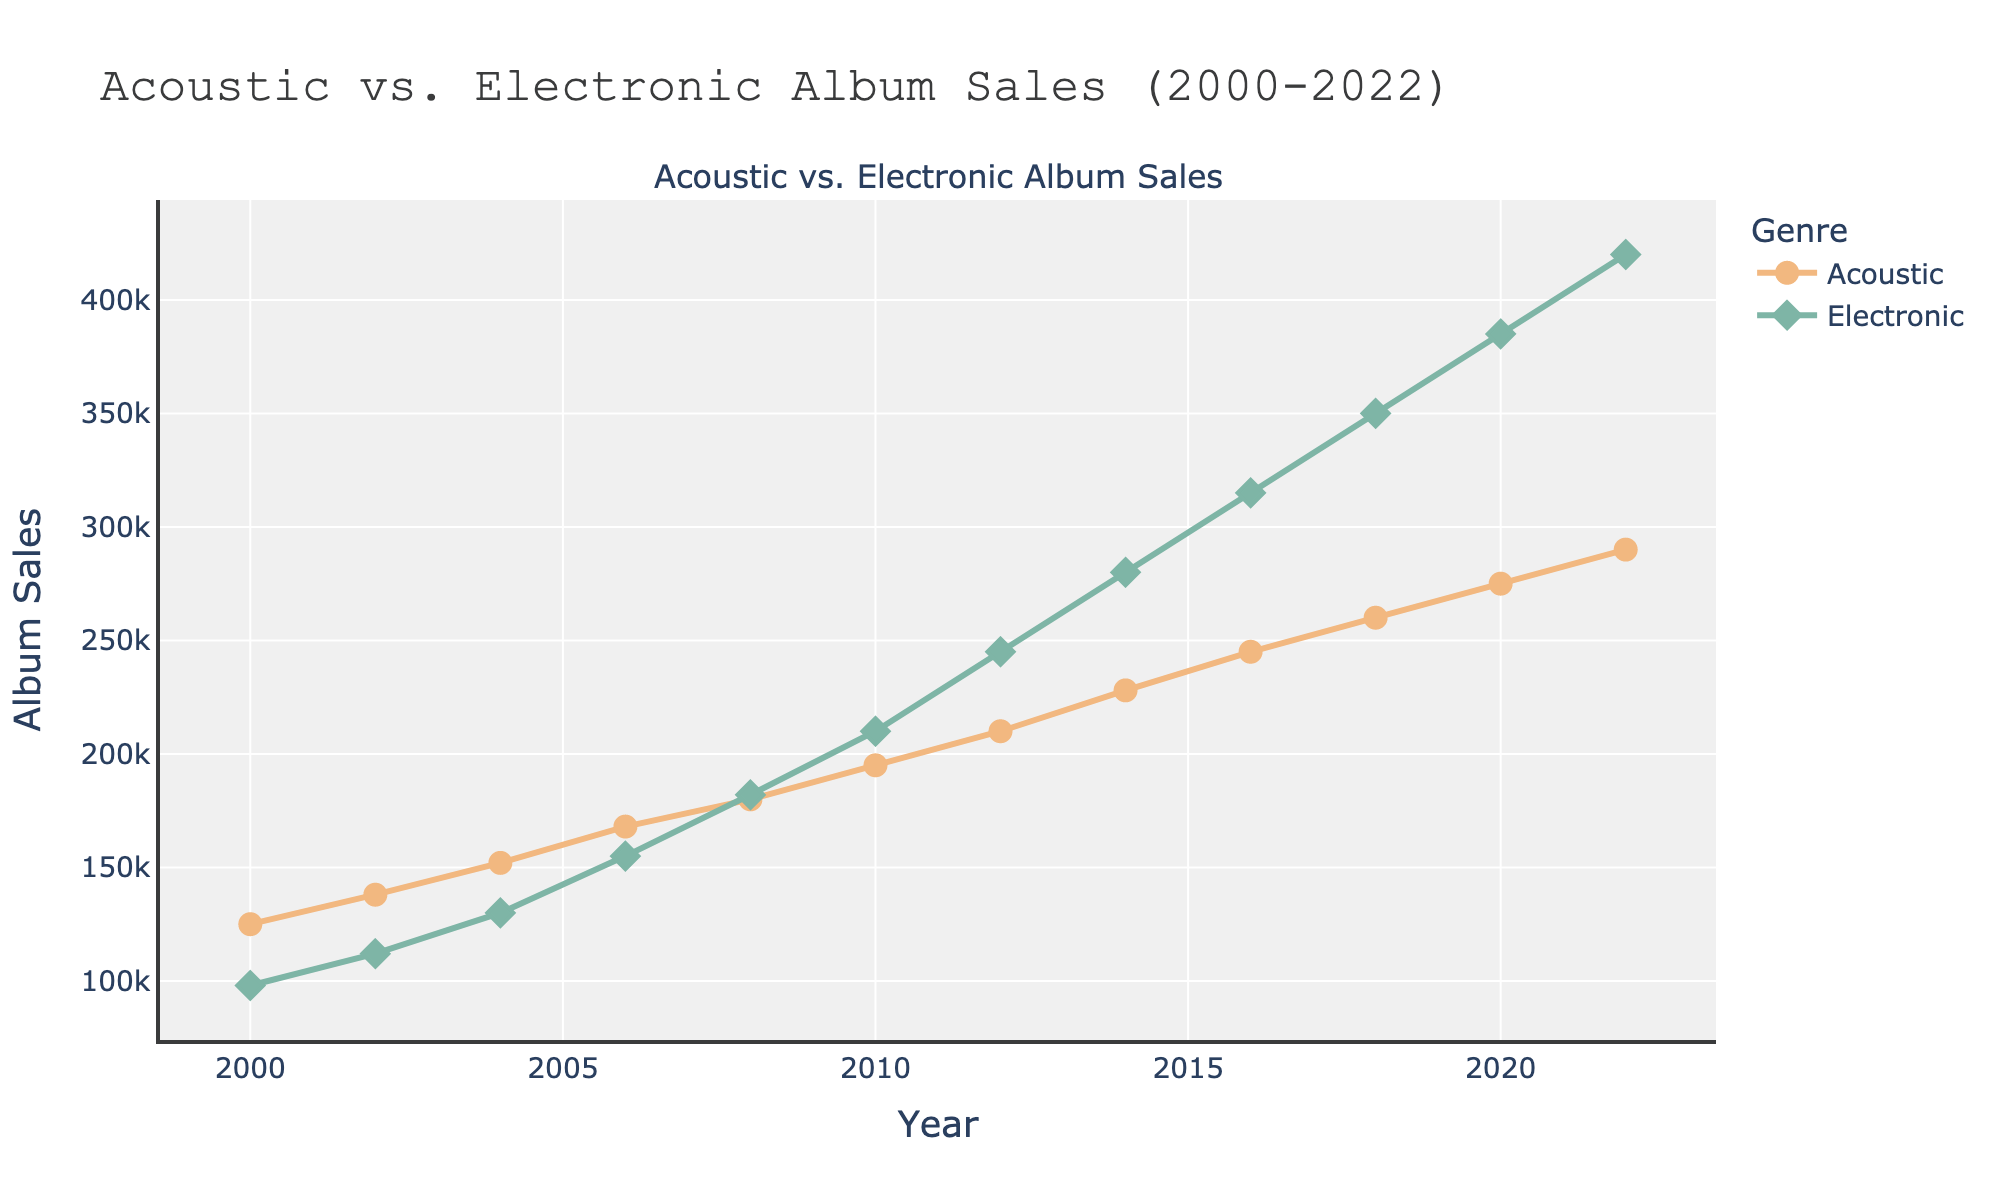What genre had higher album sales in 2022? The 2022 data points show that "Electronic Album Sales" reached 420,000 while "Acoustic Album Sales" reached 290,000. Comparing these values, Electronic Album Sales were higher.
Answer: Electronic Between which years did Acoustic album sales surpass Electronic album sales? By observing the data points within the graph, Acoustic album sales were consistently higher than Electronic album sales from 2000 until 2008. From 2010 onward, Electronic album sales overtook Acoustic album sales.
Answer: 2000-2008 What is the total increase in Acoustic album sales from 2000 to 2022? The Acoustic album sales in 2000 were 125,000 and increased to 290,000 in 2022. So, the total increase is calculated as 290,000 - 125,000 = 165,000.
Answer: 165,000 How much did Electronic album sales increase between 2008 and 2012? Electronic album sales rose from 182,000 in 2008 to 245,000 in 2012. The increase is calculated as 245,000 - 182,000 = 63,000.
Answer: 63,000 Did Acoustic album sales ever decrease during the specified period? Looking at each data point for Acoustic album sales over the years, we see a consistent increase; there is no year where sales decreased.
Answer: No What are the sales differences between Acoustic and Electronic albums in 2004? Acoustic album sales in 2004 were 152,000, while Electronic album sales were 130,000. The difference is calculated as 152,000 - 130,000 = 22,000.
Answer: 22,000 Compare the growth rates of Acoustic and Electronic album sales from 2000 to 2006. For Acoustic albums: (168,000 - 125,000) / 6 = 7,167 per year. For Electronic albums: (155,000 - 98,000) / 6 = 9,500 per year. The growth rate for Electronic album sales is higher.
Answer: Electronic What was the average sales for both genres in 2016? Acoustic sales in 2016 = 245,000. Electronic sales in 2016 = 315,000. Average = (245,000 + 315,000) / 2 = 280,000.
Answer: 280,000 Identify the year when Electronic album sales first surpassed Acoustic album sales. By analyzing each year's sales data, the crossover happened in 2008 when Electronic album sales were 182,000, which surpassed Acoustic album sales of 180,000.
Answer: 2008 